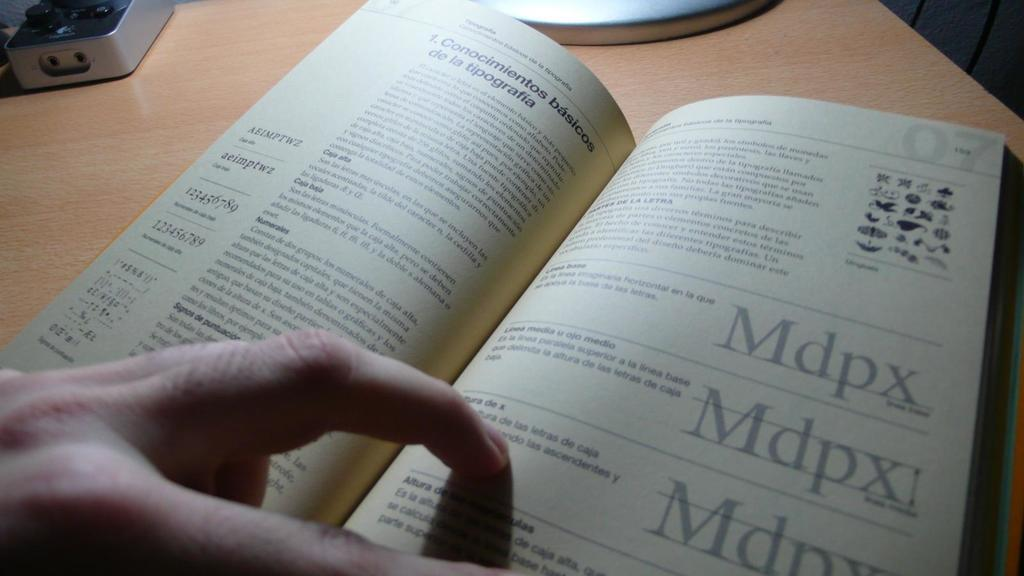<image>
Present a compact description of the photo's key features. A text book writen in a foreign language with Mdpx repeated on the page. 